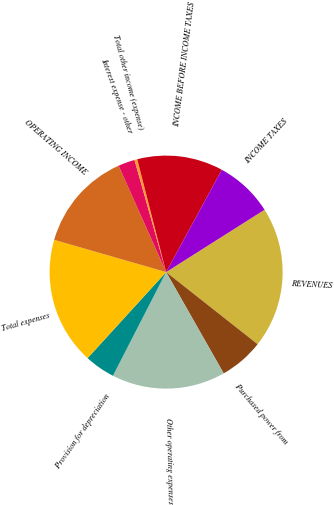Convert chart to OTSL. <chart><loc_0><loc_0><loc_500><loc_500><pie_chart><fcel>REVENUES<fcel>Purchased power from<fcel>Other operating expenses<fcel>Provision for depreciation<fcel>Total expenses<fcel>OPERATING INCOME<fcel>Interest expense - other<fcel>Total other income (expense)<fcel>INCOME BEFORE INCOME TAXES<fcel>INCOME TAXES<nl><fcel>19.61%<fcel>6.15%<fcel>15.77%<fcel>4.23%<fcel>17.69%<fcel>13.85%<fcel>2.31%<fcel>0.39%<fcel>11.92%<fcel>8.08%<nl></chart> 